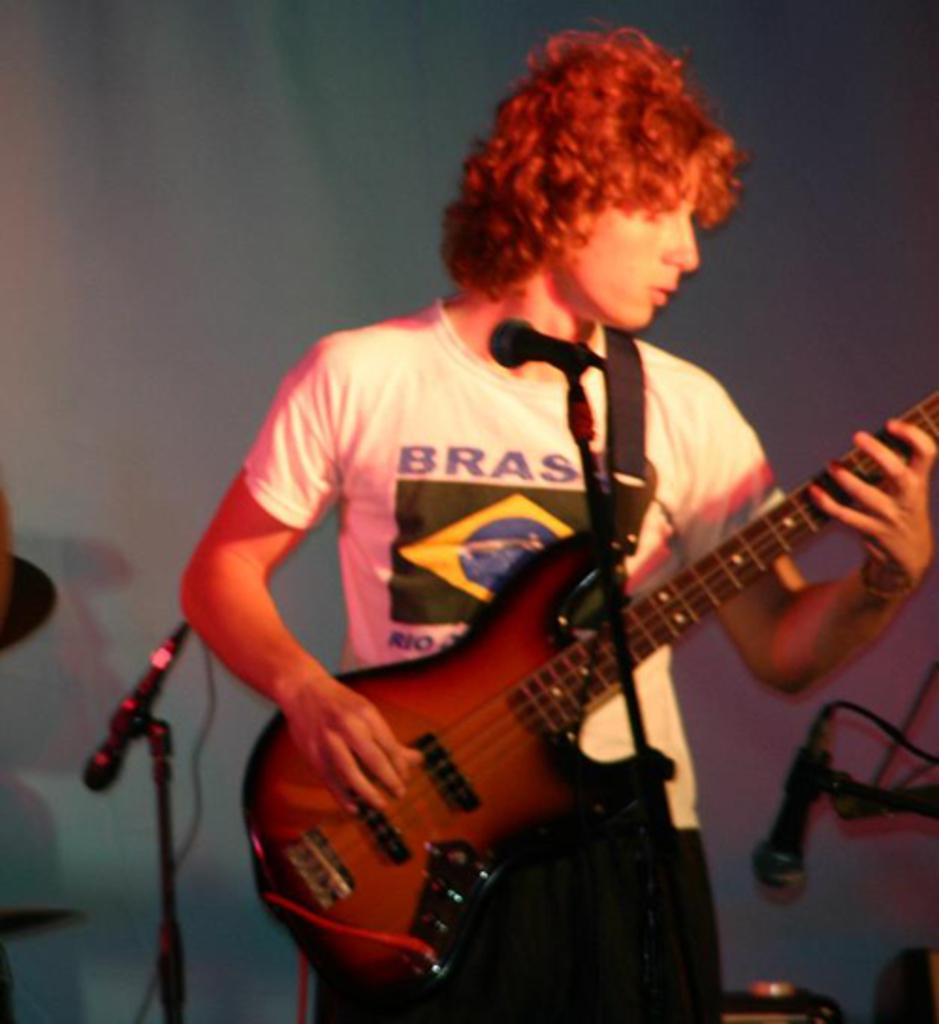Who is the main subject in the image? There is a man in the image. What is the man doing in the image? The man is standing in front of a microphone and playing a guitar. How many microphones are visible in the image? There is at least one microphone in the image. What type of ornament is hanging from the guitar in the image? There is no ornament hanging from the guitar in the image. How many apples are visible on the table in the image? There is no table or apples present in the image. 